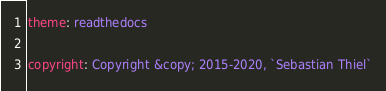<code> <loc_0><loc_0><loc_500><loc_500><_YAML_>theme: readthedocs

copyright: Copyright &copy; 2015-2020, `Sebastian Thiel`

</code> 